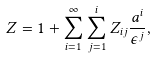Convert formula to latex. <formula><loc_0><loc_0><loc_500><loc_500>Z = 1 + \sum _ { i = 1 } ^ { \infty } \sum _ { j = 1 } ^ { i } Z _ { i j } \frac { a ^ { i } } { \epsilon ^ { j } } ,</formula> 